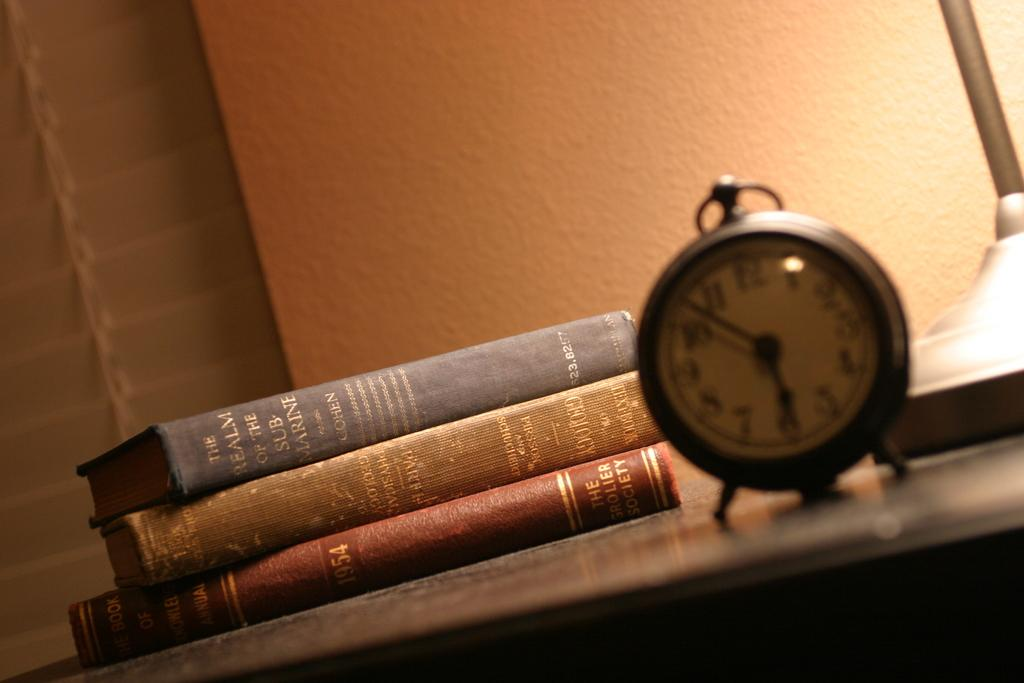<image>
Offer a succinct explanation of the picture presented. A book titled "The Realm of the Submarine" sits on top of two other books. 